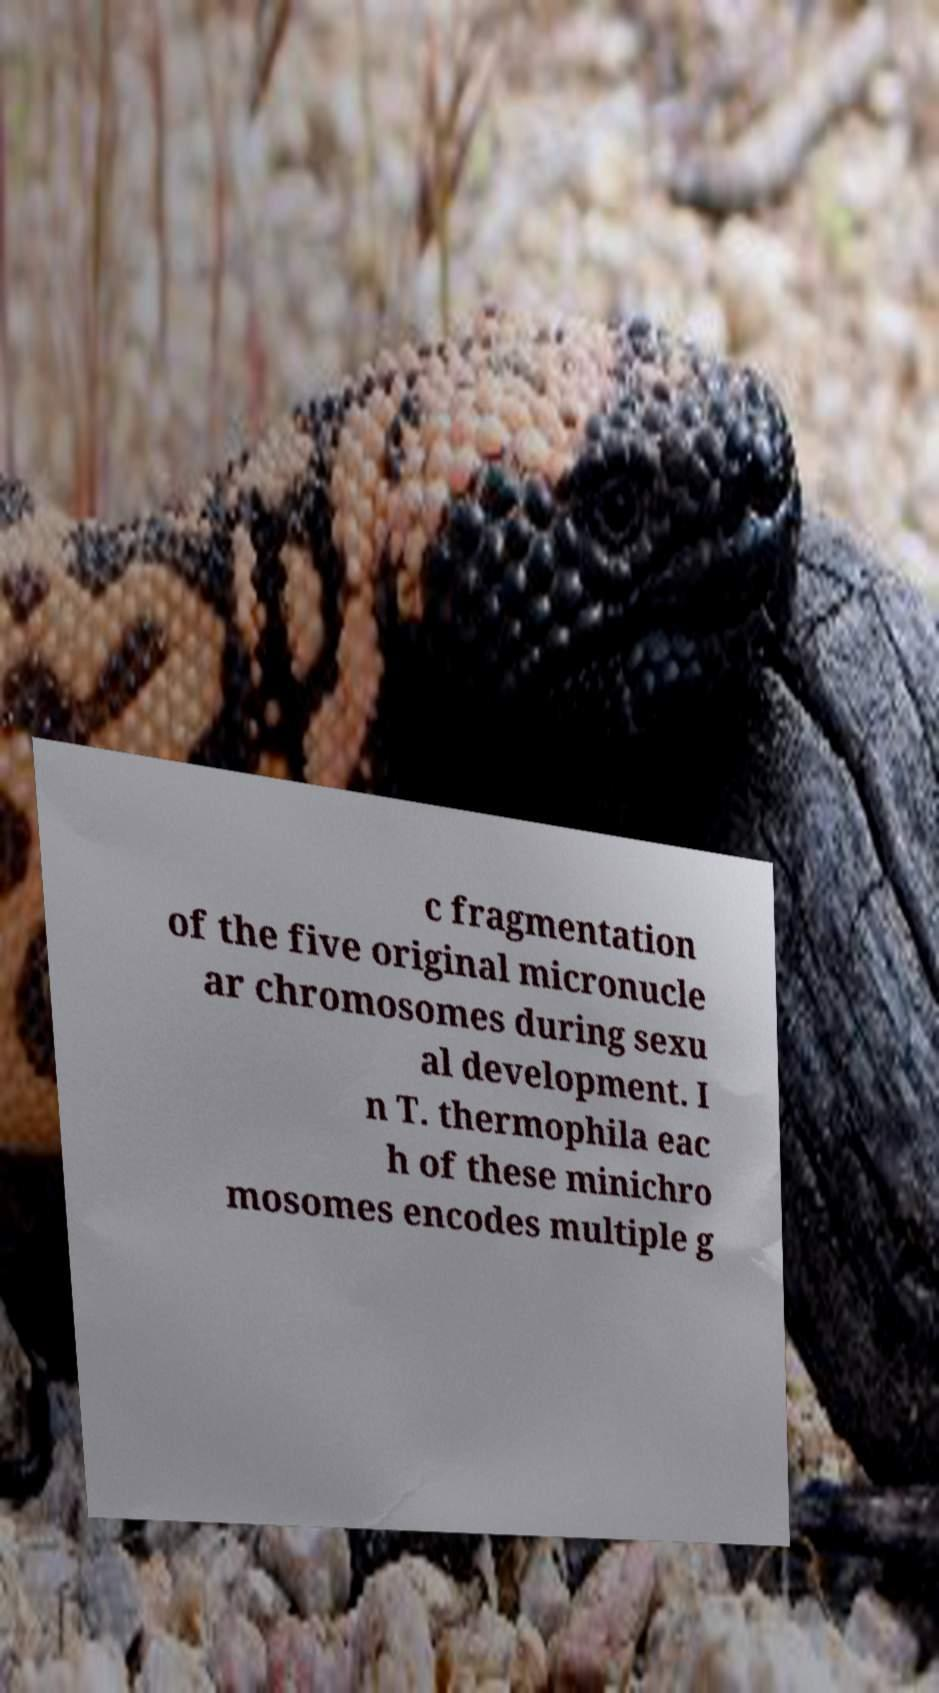Could you extract and type out the text from this image? c fragmentation of the five original micronucle ar chromosomes during sexu al development. I n T. thermophila eac h of these minichro mosomes encodes multiple g 